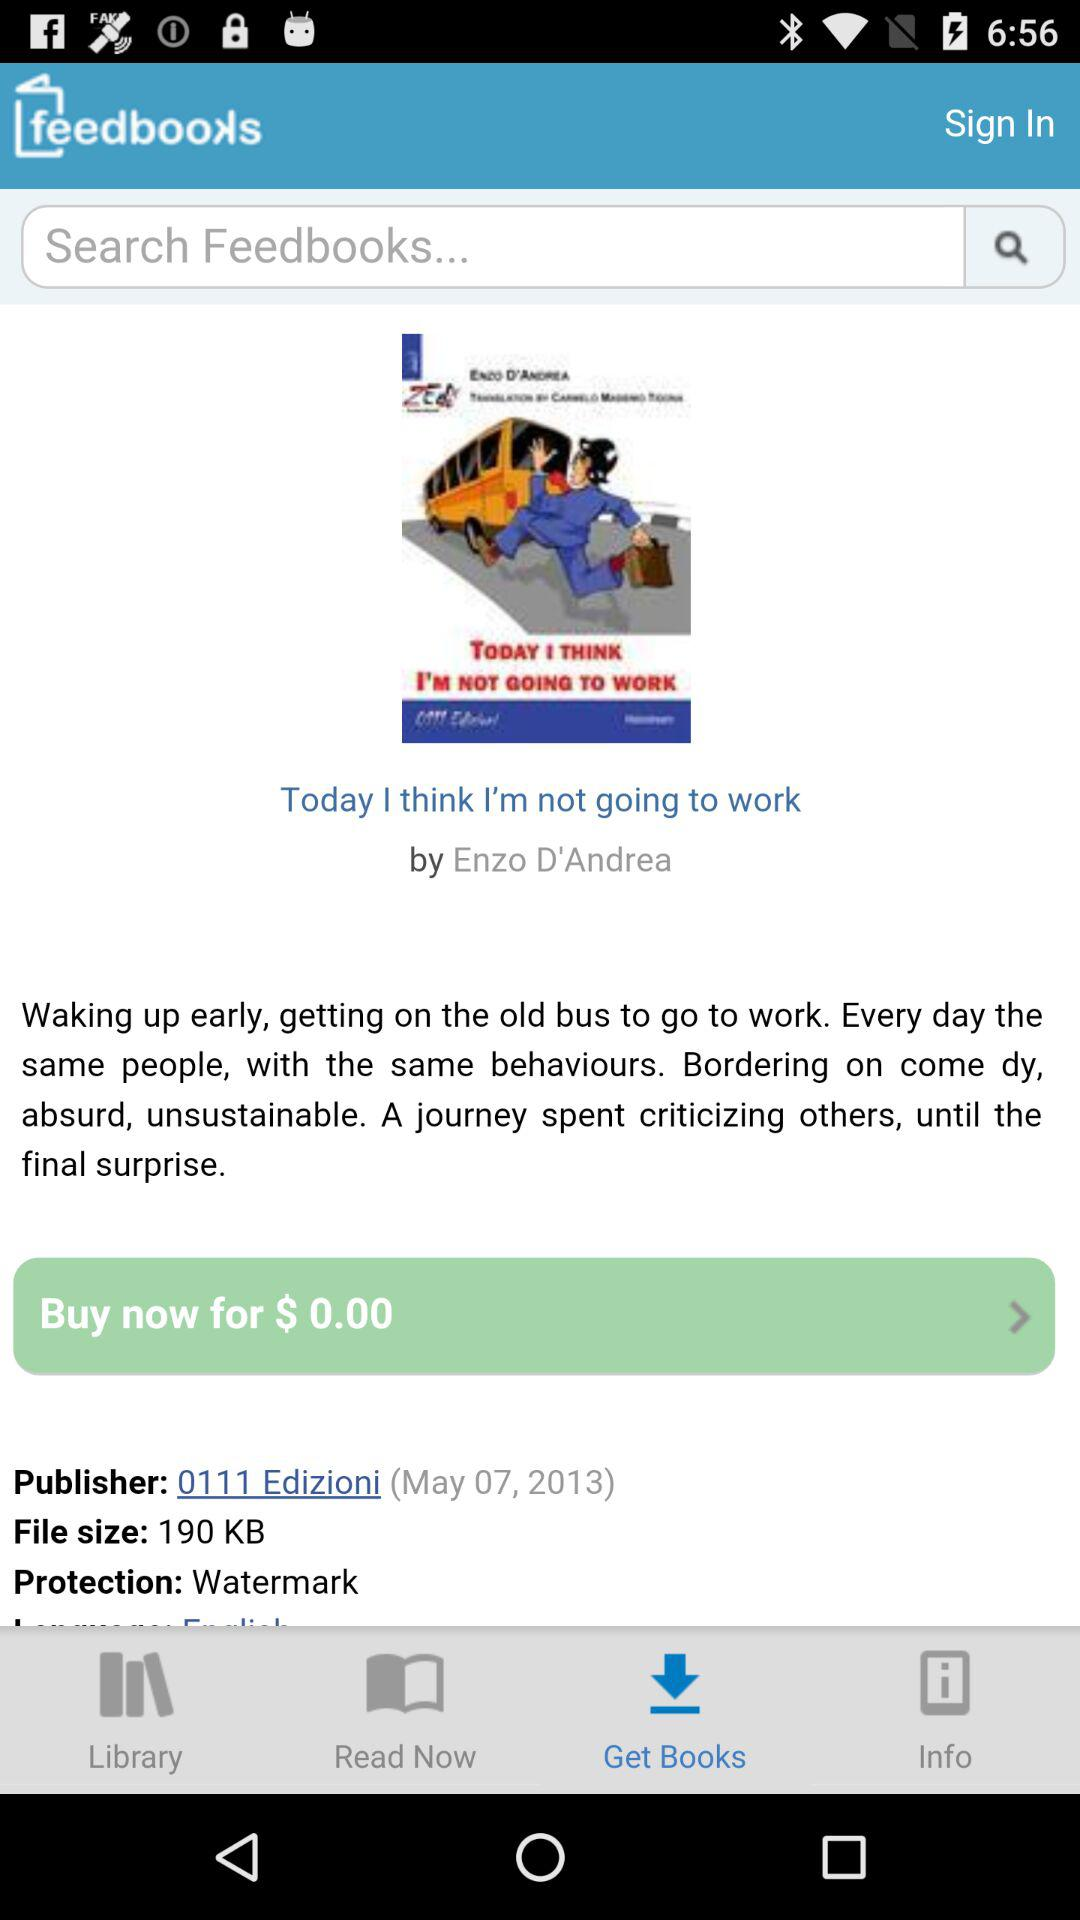What is the file size of the book?
Answer the question using a single word or phrase. 190 KB 